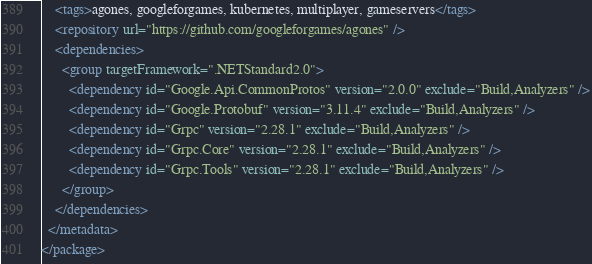<code> <loc_0><loc_0><loc_500><loc_500><_XML_>    <tags>agones, googleforgames, kubernetes, multiplayer, gameservers</tags>
    <repository url="https://github.com/googleforgames/agones" />
    <dependencies>
      <group targetFramework=".NETStandard2.0">
        <dependency id="Google.Api.CommonProtos" version="2.0.0" exclude="Build,Analyzers" />
        <dependency id="Google.Protobuf" version="3.11.4" exclude="Build,Analyzers" />
        <dependency id="Grpc" version="2.28.1" exclude="Build,Analyzers" />
        <dependency id="Grpc.Core" version="2.28.1" exclude="Build,Analyzers" />
        <dependency id="Grpc.Tools" version="2.28.1" exclude="Build,Analyzers" />
      </group>
    </dependencies>
  </metadata>
</package>
</code> 